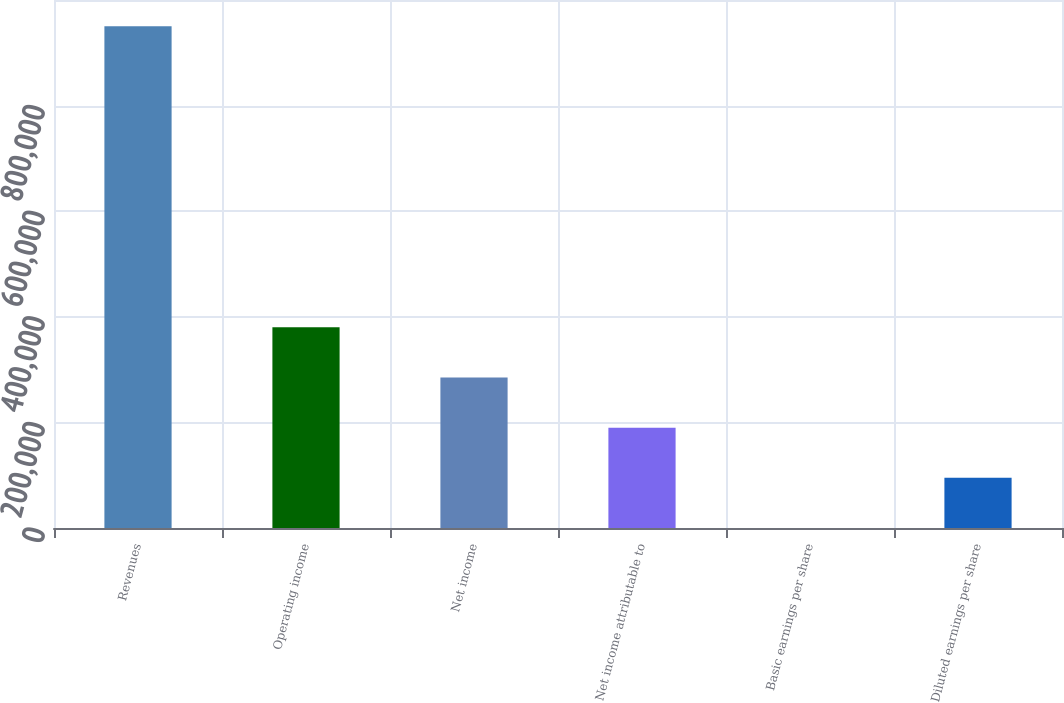<chart> <loc_0><loc_0><loc_500><loc_500><bar_chart><fcel>Revenues<fcel>Operating income<fcel>Net income<fcel>Net income attributable to<fcel>Basic earnings per share<fcel>Diluted earnings per share<nl><fcel>950187<fcel>380075<fcel>285056<fcel>190038<fcel>0.16<fcel>95018.8<nl></chart> 